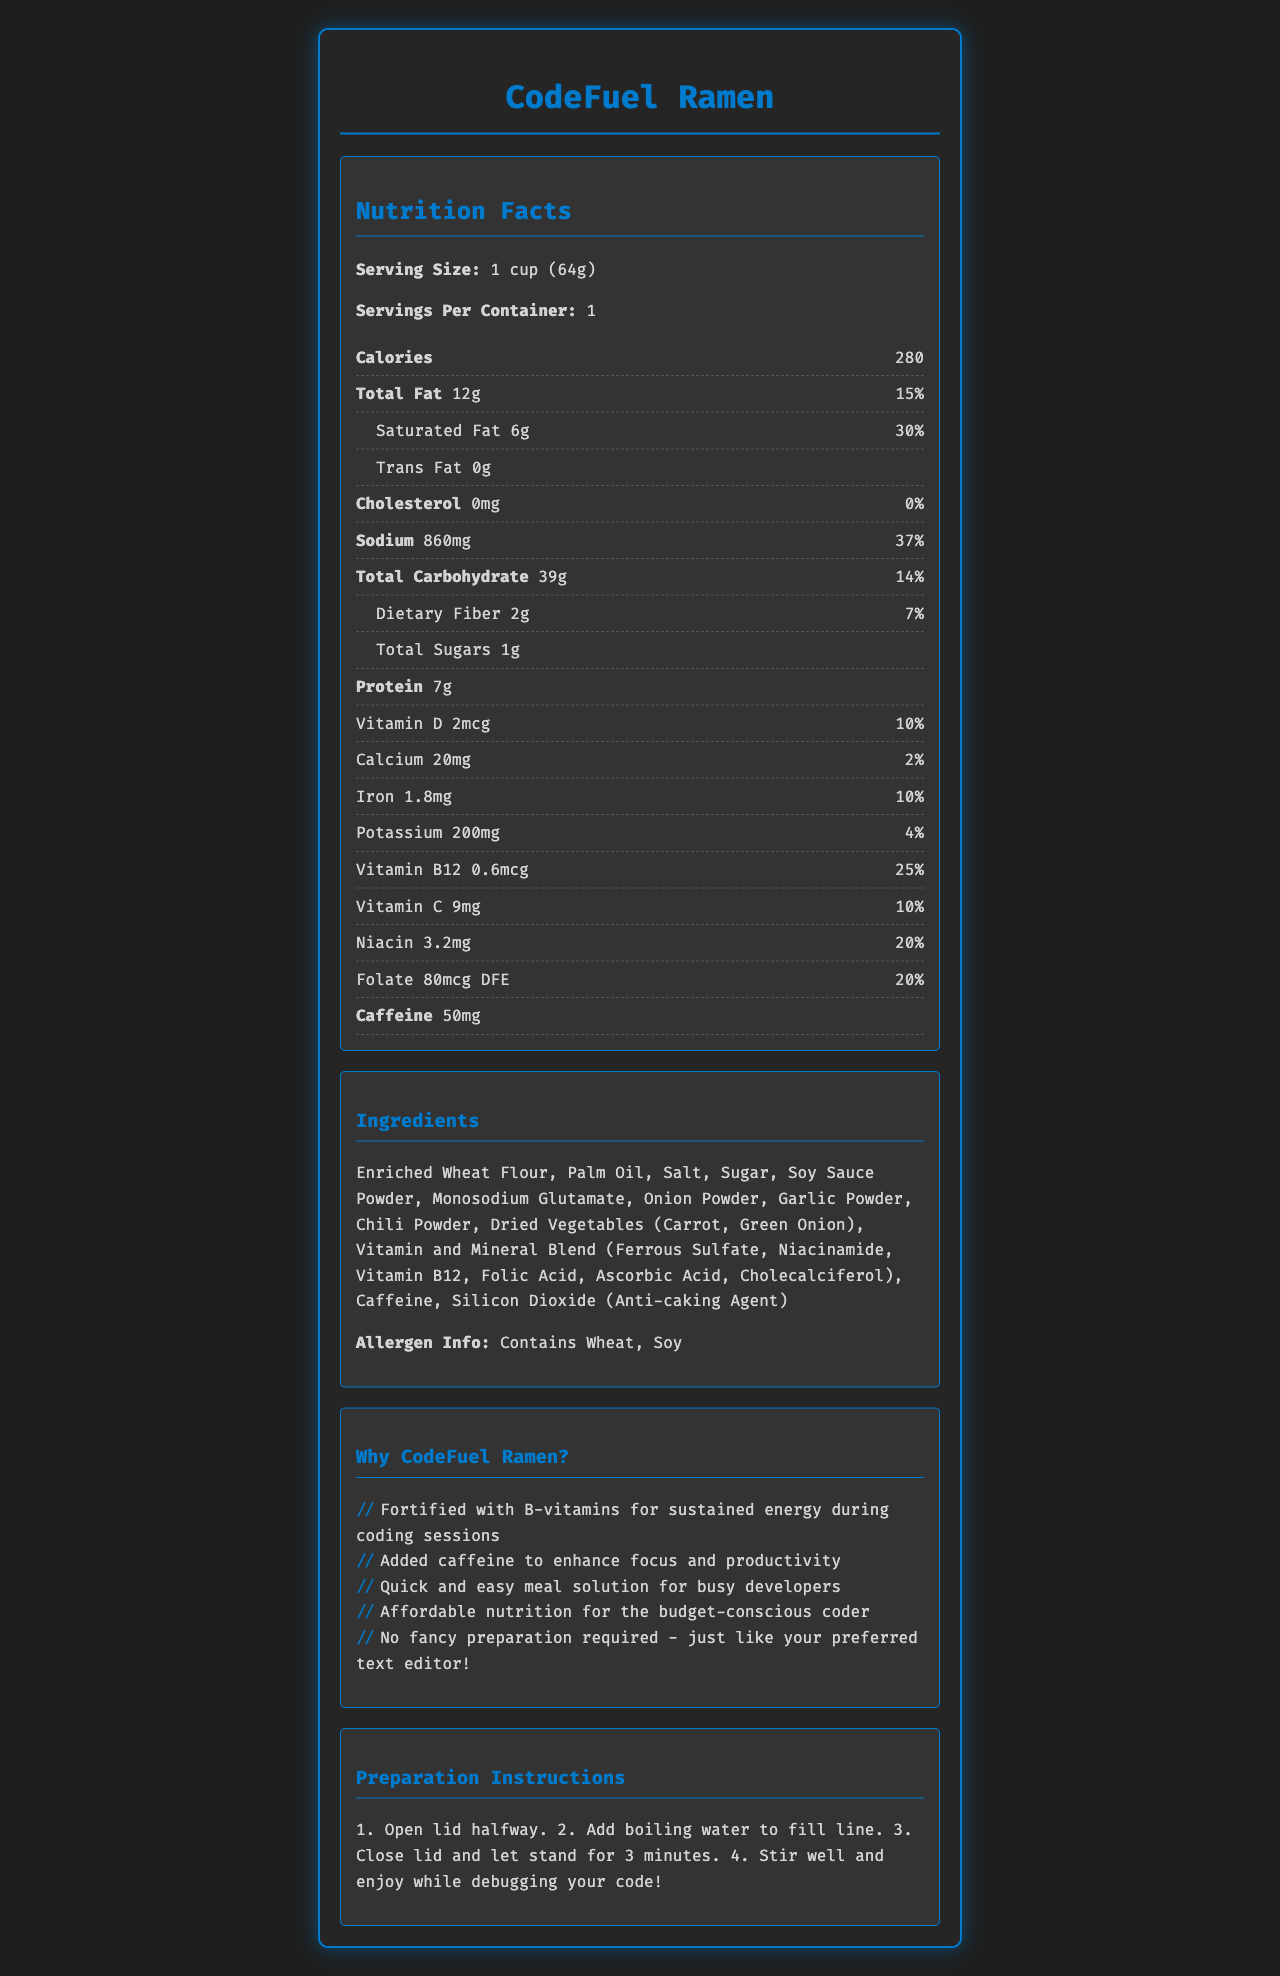what is the serving size? The serving size is listed directly under the Nutrition Facts title as "Serving Size: 1 cup (64g)".
Answer: 1 cup (64g) how much caffeine is in one serving? The amount of caffeine is explicitly mentioned under the "Caffeine" section in the Nutrition Facts.
Answer: 50mg what are the main ingredients? All the ingredients are listed in the Ingredients section.
Answer: Enriched Wheat Flour, Palm Oil, Salt, Sugar, Soy Sauce Powder, Monosodium Glutamate, Onion Powder, Garlic Powder, Chili Powder, Dried Vegetables, Vitamin and Mineral Blend, Caffeine, Silicon Dioxide how many grams of dietary fiber per serving? The amount of dietary fiber is listed as "Dietary Fiber 2g".
Answer: 2g does this product contain any allergens? Allergen information is given at the end of the Ingredients section, mentioning that it contains wheat and soy.
Answer: Yes What is the total amount of fat in one serving? A. 5g B. 12g C. 15g D. 20g The total amount of fat per serving is specified as "Total Fat 12g" in the Nutrition Facts section.
Answer: B how many calories are there per serving? A. 200 B. 280 C. 300 The number of calories per serving is "280" listed under the Calories section.
Answer: B does the product contain any vitamin B12? The Nutrition Facts lists "Vitamin B12 0.6mcg".
Answer: Yes is this product fortified with vitamins? The document mentions it is fortified with vitamins D, B12, C, and more, which is evident both from the marketing claims section and the list of vitamins in the Nutrition Facts.
Answer: Yes Can you summarize the main idea of the nutrition facts label? The document details the nutritional content, ingredients, allergen info, marketing claims, and preparation instructions, highlighting that the product is affordable, fortified with energy-sustaining vitamins, and quick to prepare.
Answer: CodeFuel Ramen is a vitamin-fortified instant noodle cup designed for budget-conscious developers, offering quick preparation and energy-boosting nutrients including caffeine and B-vitamins. How much potassium is present in one serving? The amount of potassium per serving is specified as "Potassium 200mg" in the Nutrition Facts.
Answer: 200mg what percentage of daily value of sodium does one serving contain? The daily value percentage for sodium in one serving is listed as 37%.
Answer: 37% Is this product cholesterol-free? The Nutrition Facts section shows cholesterol as "0mg" with a daily value of "0%".
Answer: Yes what is the name of the product? The name of the product is displayed prominently at the top of the document.
Answer: CodeFuel Ramen is the exact amount of trans fat provided in the nutrition facts? The nutrition facts section lists Trans Fat but does not provide an exact amount.
Answer: No What are the preparation instructions for the product? The preparation instructions are detailed towards the end of the document under the Preparation Instructions section, guiding how to prepare the noodle cup.
Answer: 1. Open lid halfway. 2. Add boiling water to fill line. 3. Close lid and let stand for 3 minutes. 4. Stir well and enjoy while debugging your code! Does this document provide information about the price of the product? The document focuses on nutritional information, ingredients, marketing claims, and preparation instructions, but does not mention the price.
Answer: Not enough information 